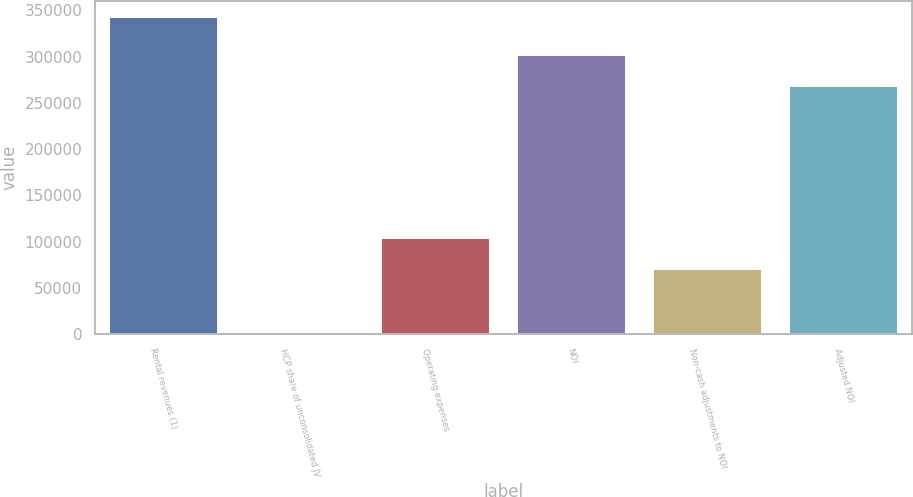Convert chart. <chart><loc_0><loc_0><loc_500><loc_500><bar_chart><fcel>Rental revenues (1)<fcel>HCP share of unconsolidated JV<fcel>Operating expenses<fcel>NOI<fcel>Non-cash adjustments to NOI<fcel>Adjusted NOI<nl><fcel>342984<fcel>1612<fcel>104024<fcel>302006<fcel>69886.4<fcel>267869<nl></chart> 